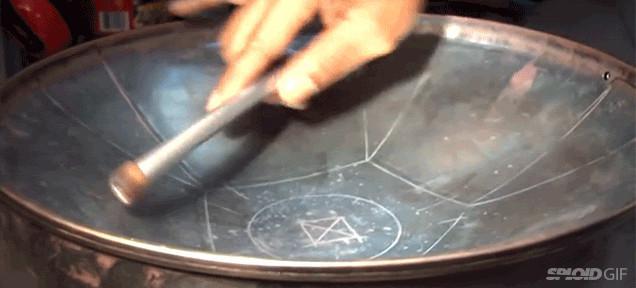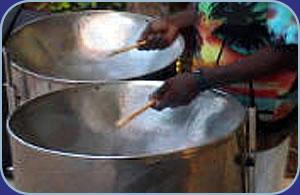The first image is the image on the left, the second image is the image on the right. Considering the images on both sides, is "One image features at least one steel drum with a concave hammered-look bowl, and the other image shows one person holding two drum sticks inside one drum's bowl." valid? Answer yes or no. No. The first image is the image on the left, the second image is the image on the right. For the images shown, is this caption "In exactly one image someone is playing steel drums." true? Answer yes or no. No. 